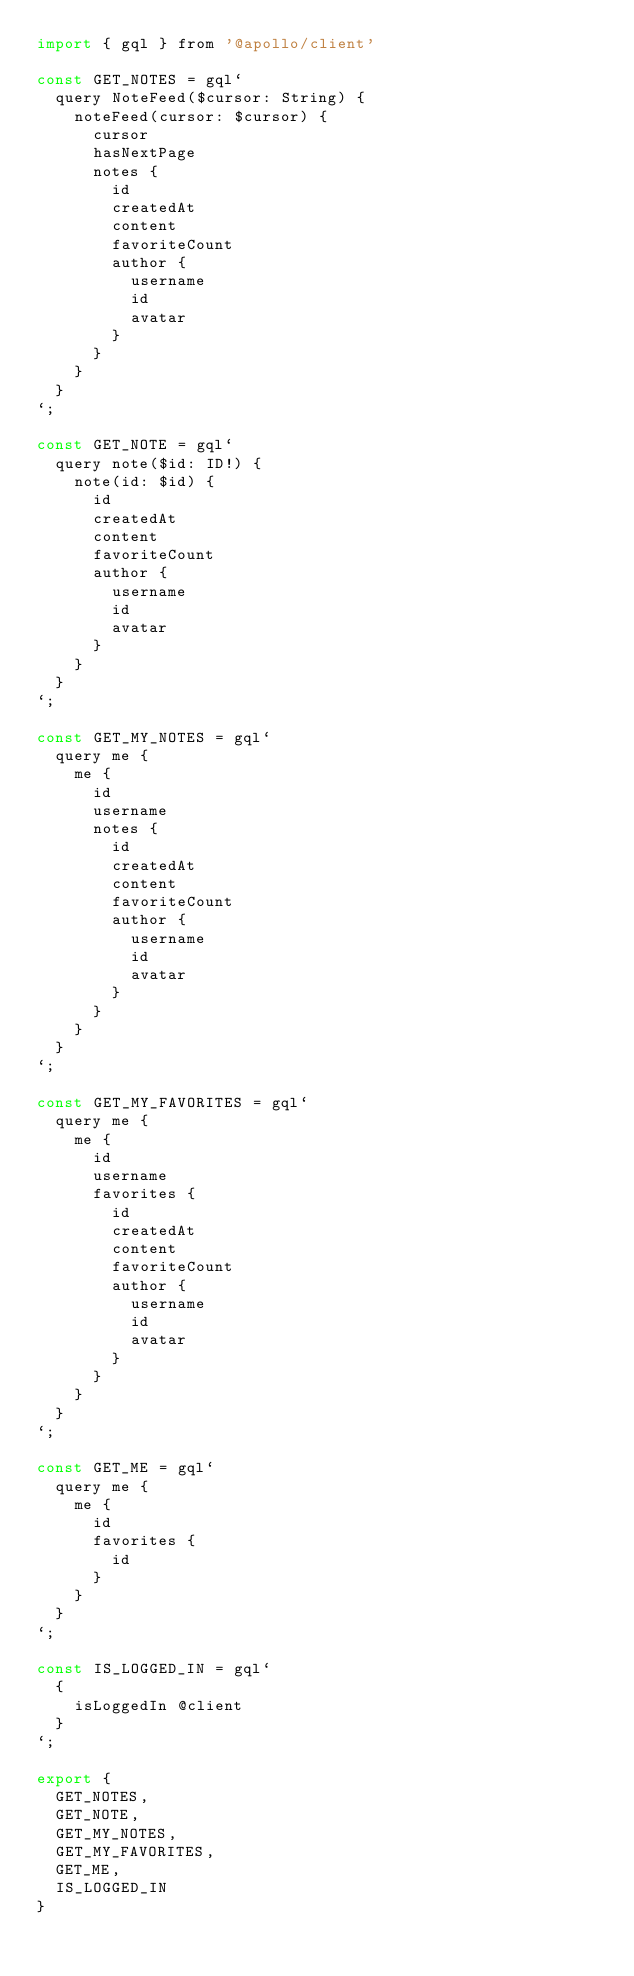<code> <loc_0><loc_0><loc_500><loc_500><_JavaScript_>import { gql } from '@apollo/client'

const GET_NOTES = gql`
  query NoteFeed($cursor: String) {
    noteFeed(cursor: $cursor) {
      cursor
      hasNextPage
      notes {
        id
        createdAt
        content
        favoriteCount
        author {
          username
          id
          avatar
        }
      }
    }
  }
`;

const GET_NOTE = gql`
  query note($id: ID!) {
    note(id: $id) {
      id
      createdAt
      content
      favoriteCount
      author {
        username
        id
        avatar
      }
    }
  }
`;

const GET_MY_NOTES = gql`
  query me {
    me {
      id
      username
      notes {
        id
        createdAt
        content
        favoriteCount
        author {
          username
          id
          avatar
        }
      }
    }
  }
`;

const GET_MY_FAVORITES = gql`
  query me {
    me {
      id
      username
      favorites {
        id
        createdAt
        content
        favoriteCount
        author {
          username
          id
          avatar
        }
      }
    }
  }
`;

const GET_ME = gql`
  query me {
    me {
      id
      favorites {
        id
      }
    }
  }
`;

const IS_LOGGED_IN = gql`
  {
    isLoggedIn @client
  }
`;

export { 
  GET_NOTES, 
  GET_NOTE, 
  GET_MY_NOTES, 
  GET_MY_FAVORITES,
  GET_ME,
  IS_LOGGED_IN 
}</code> 